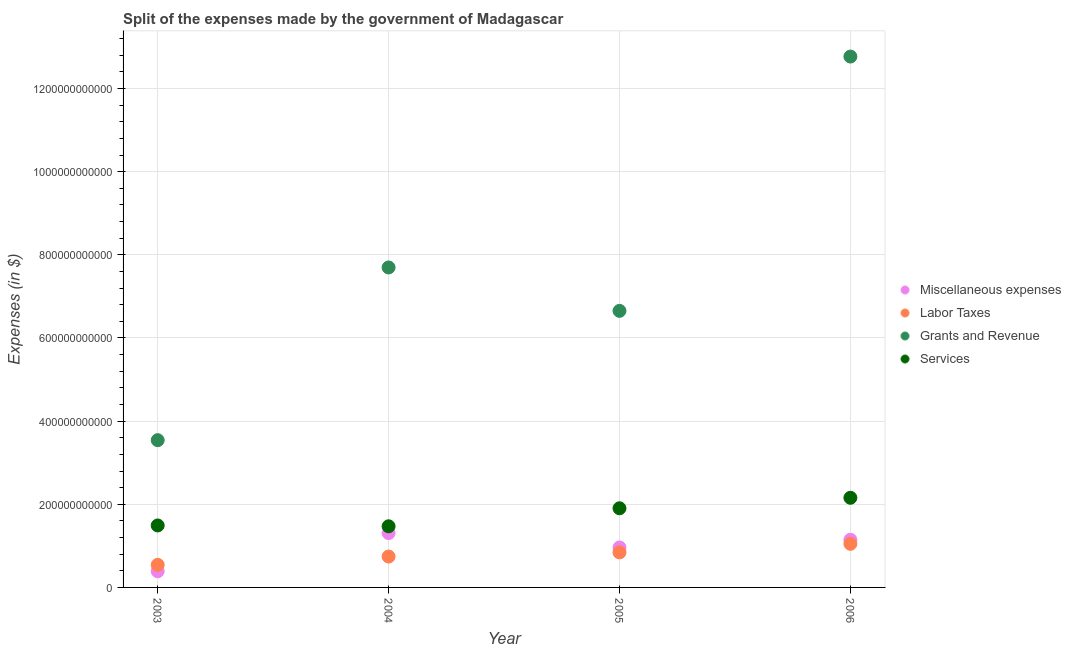How many different coloured dotlines are there?
Your answer should be compact. 4. Is the number of dotlines equal to the number of legend labels?
Keep it short and to the point. Yes. What is the amount spent on labor taxes in 2003?
Provide a succinct answer. 5.43e+1. Across all years, what is the maximum amount spent on labor taxes?
Provide a short and direct response. 1.05e+11. Across all years, what is the minimum amount spent on labor taxes?
Your response must be concise. 5.43e+1. In which year was the amount spent on services minimum?
Offer a very short reply. 2004. What is the total amount spent on miscellaneous expenses in the graph?
Ensure brevity in your answer.  3.80e+11. What is the difference between the amount spent on miscellaneous expenses in 2003 and that in 2005?
Give a very brief answer. -5.72e+1. What is the difference between the amount spent on miscellaneous expenses in 2003 and the amount spent on services in 2006?
Your answer should be compact. -1.77e+11. What is the average amount spent on labor taxes per year?
Offer a very short reply. 7.94e+1. In the year 2006, what is the difference between the amount spent on labor taxes and amount spent on services?
Ensure brevity in your answer.  -1.11e+11. In how many years, is the amount spent on services greater than 120000000000 $?
Make the answer very short. 4. What is the ratio of the amount spent on grants and revenue in 2005 to that in 2006?
Your response must be concise. 0.52. Is the amount spent on services in 2003 less than that in 2005?
Keep it short and to the point. Yes. Is the difference between the amount spent on grants and revenue in 2003 and 2006 greater than the difference between the amount spent on labor taxes in 2003 and 2006?
Your response must be concise. No. What is the difference between the highest and the second highest amount spent on services?
Ensure brevity in your answer.  2.52e+1. What is the difference between the highest and the lowest amount spent on services?
Offer a terse response. 6.86e+1. Does the amount spent on services monotonically increase over the years?
Ensure brevity in your answer.  No. Is the amount spent on miscellaneous expenses strictly greater than the amount spent on labor taxes over the years?
Make the answer very short. No. What is the difference between two consecutive major ticks on the Y-axis?
Your response must be concise. 2.00e+11. Does the graph contain grids?
Your response must be concise. Yes. Where does the legend appear in the graph?
Your answer should be very brief. Center right. How are the legend labels stacked?
Keep it short and to the point. Vertical. What is the title of the graph?
Offer a terse response. Split of the expenses made by the government of Madagascar. What is the label or title of the Y-axis?
Keep it short and to the point. Expenses (in $). What is the Expenses (in $) in Miscellaneous expenses in 2003?
Your answer should be compact. 3.89e+1. What is the Expenses (in $) in Labor Taxes in 2003?
Provide a short and direct response. 5.43e+1. What is the Expenses (in $) of Grants and Revenue in 2003?
Give a very brief answer. 3.54e+11. What is the Expenses (in $) in Services in 2003?
Ensure brevity in your answer.  1.49e+11. What is the Expenses (in $) of Miscellaneous expenses in 2004?
Your answer should be very brief. 1.31e+11. What is the Expenses (in $) in Labor Taxes in 2004?
Make the answer very short. 7.43e+1. What is the Expenses (in $) in Grants and Revenue in 2004?
Provide a short and direct response. 7.70e+11. What is the Expenses (in $) of Services in 2004?
Ensure brevity in your answer.  1.47e+11. What is the Expenses (in $) of Miscellaneous expenses in 2005?
Your answer should be compact. 9.61e+1. What is the Expenses (in $) in Labor Taxes in 2005?
Provide a short and direct response. 8.43e+1. What is the Expenses (in $) in Grants and Revenue in 2005?
Offer a very short reply. 6.65e+11. What is the Expenses (in $) in Services in 2005?
Offer a very short reply. 1.90e+11. What is the Expenses (in $) in Miscellaneous expenses in 2006?
Keep it short and to the point. 1.15e+11. What is the Expenses (in $) of Labor Taxes in 2006?
Offer a very short reply. 1.05e+11. What is the Expenses (in $) of Grants and Revenue in 2006?
Provide a short and direct response. 1.28e+12. What is the Expenses (in $) of Services in 2006?
Your answer should be compact. 2.16e+11. Across all years, what is the maximum Expenses (in $) of Miscellaneous expenses?
Offer a very short reply. 1.31e+11. Across all years, what is the maximum Expenses (in $) in Labor Taxes?
Your response must be concise. 1.05e+11. Across all years, what is the maximum Expenses (in $) in Grants and Revenue?
Offer a very short reply. 1.28e+12. Across all years, what is the maximum Expenses (in $) of Services?
Your answer should be compact. 2.16e+11. Across all years, what is the minimum Expenses (in $) of Miscellaneous expenses?
Offer a very short reply. 3.89e+1. Across all years, what is the minimum Expenses (in $) in Labor Taxes?
Your answer should be very brief. 5.43e+1. Across all years, what is the minimum Expenses (in $) in Grants and Revenue?
Offer a very short reply. 3.54e+11. Across all years, what is the minimum Expenses (in $) of Services?
Make the answer very short. 1.47e+11. What is the total Expenses (in $) of Miscellaneous expenses in the graph?
Make the answer very short. 3.80e+11. What is the total Expenses (in $) in Labor Taxes in the graph?
Provide a short and direct response. 3.18e+11. What is the total Expenses (in $) in Grants and Revenue in the graph?
Provide a succinct answer. 3.07e+12. What is the total Expenses (in $) in Services in the graph?
Offer a very short reply. 7.02e+11. What is the difference between the Expenses (in $) in Miscellaneous expenses in 2003 and that in 2004?
Offer a terse response. -9.17e+1. What is the difference between the Expenses (in $) in Labor Taxes in 2003 and that in 2004?
Give a very brief answer. -1.99e+1. What is the difference between the Expenses (in $) in Grants and Revenue in 2003 and that in 2004?
Keep it short and to the point. -4.15e+11. What is the difference between the Expenses (in $) in Services in 2003 and that in 2004?
Offer a terse response. 1.99e+09. What is the difference between the Expenses (in $) in Miscellaneous expenses in 2003 and that in 2005?
Ensure brevity in your answer.  -5.72e+1. What is the difference between the Expenses (in $) of Labor Taxes in 2003 and that in 2005?
Give a very brief answer. -3.00e+1. What is the difference between the Expenses (in $) in Grants and Revenue in 2003 and that in 2005?
Your answer should be compact. -3.11e+11. What is the difference between the Expenses (in $) in Services in 2003 and that in 2005?
Keep it short and to the point. -4.14e+1. What is the difference between the Expenses (in $) of Miscellaneous expenses in 2003 and that in 2006?
Your response must be concise. -7.57e+1. What is the difference between the Expenses (in $) of Labor Taxes in 2003 and that in 2006?
Make the answer very short. -5.06e+1. What is the difference between the Expenses (in $) of Grants and Revenue in 2003 and that in 2006?
Give a very brief answer. -9.23e+11. What is the difference between the Expenses (in $) of Services in 2003 and that in 2006?
Your response must be concise. -6.66e+1. What is the difference between the Expenses (in $) in Miscellaneous expenses in 2004 and that in 2005?
Ensure brevity in your answer.  3.46e+1. What is the difference between the Expenses (in $) of Labor Taxes in 2004 and that in 2005?
Give a very brief answer. -1.00e+1. What is the difference between the Expenses (in $) of Grants and Revenue in 2004 and that in 2005?
Your response must be concise. 1.04e+11. What is the difference between the Expenses (in $) of Services in 2004 and that in 2005?
Give a very brief answer. -4.33e+1. What is the difference between the Expenses (in $) in Miscellaneous expenses in 2004 and that in 2006?
Give a very brief answer. 1.61e+1. What is the difference between the Expenses (in $) of Labor Taxes in 2004 and that in 2006?
Provide a succinct answer. -3.06e+1. What is the difference between the Expenses (in $) of Grants and Revenue in 2004 and that in 2006?
Your answer should be very brief. -5.07e+11. What is the difference between the Expenses (in $) of Services in 2004 and that in 2006?
Offer a very short reply. -6.86e+1. What is the difference between the Expenses (in $) in Miscellaneous expenses in 2005 and that in 2006?
Your answer should be compact. -1.85e+1. What is the difference between the Expenses (in $) in Labor Taxes in 2005 and that in 2006?
Offer a terse response. -2.06e+1. What is the difference between the Expenses (in $) of Grants and Revenue in 2005 and that in 2006?
Your answer should be very brief. -6.12e+11. What is the difference between the Expenses (in $) of Services in 2005 and that in 2006?
Keep it short and to the point. -2.52e+1. What is the difference between the Expenses (in $) in Miscellaneous expenses in 2003 and the Expenses (in $) in Labor Taxes in 2004?
Give a very brief answer. -3.53e+1. What is the difference between the Expenses (in $) in Miscellaneous expenses in 2003 and the Expenses (in $) in Grants and Revenue in 2004?
Give a very brief answer. -7.31e+11. What is the difference between the Expenses (in $) of Miscellaneous expenses in 2003 and the Expenses (in $) of Services in 2004?
Make the answer very short. -1.08e+11. What is the difference between the Expenses (in $) of Labor Taxes in 2003 and the Expenses (in $) of Grants and Revenue in 2004?
Your answer should be compact. -7.15e+11. What is the difference between the Expenses (in $) in Labor Taxes in 2003 and the Expenses (in $) in Services in 2004?
Your answer should be compact. -9.27e+1. What is the difference between the Expenses (in $) in Grants and Revenue in 2003 and the Expenses (in $) in Services in 2004?
Provide a short and direct response. 2.07e+11. What is the difference between the Expenses (in $) of Miscellaneous expenses in 2003 and the Expenses (in $) of Labor Taxes in 2005?
Give a very brief answer. -4.54e+1. What is the difference between the Expenses (in $) in Miscellaneous expenses in 2003 and the Expenses (in $) in Grants and Revenue in 2005?
Keep it short and to the point. -6.26e+11. What is the difference between the Expenses (in $) in Miscellaneous expenses in 2003 and the Expenses (in $) in Services in 2005?
Provide a succinct answer. -1.51e+11. What is the difference between the Expenses (in $) of Labor Taxes in 2003 and the Expenses (in $) of Grants and Revenue in 2005?
Make the answer very short. -6.11e+11. What is the difference between the Expenses (in $) in Labor Taxes in 2003 and the Expenses (in $) in Services in 2005?
Offer a very short reply. -1.36e+11. What is the difference between the Expenses (in $) of Grants and Revenue in 2003 and the Expenses (in $) of Services in 2005?
Make the answer very short. 1.64e+11. What is the difference between the Expenses (in $) of Miscellaneous expenses in 2003 and the Expenses (in $) of Labor Taxes in 2006?
Make the answer very short. -6.60e+1. What is the difference between the Expenses (in $) in Miscellaneous expenses in 2003 and the Expenses (in $) in Grants and Revenue in 2006?
Your answer should be very brief. -1.24e+12. What is the difference between the Expenses (in $) of Miscellaneous expenses in 2003 and the Expenses (in $) of Services in 2006?
Your answer should be very brief. -1.77e+11. What is the difference between the Expenses (in $) in Labor Taxes in 2003 and the Expenses (in $) in Grants and Revenue in 2006?
Provide a short and direct response. -1.22e+12. What is the difference between the Expenses (in $) in Labor Taxes in 2003 and the Expenses (in $) in Services in 2006?
Your answer should be compact. -1.61e+11. What is the difference between the Expenses (in $) of Grants and Revenue in 2003 and the Expenses (in $) of Services in 2006?
Ensure brevity in your answer.  1.39e+11. What is the difference between the Expenses (in $) in Miscellaneous expenses in 2004 and the Expenses (in $) in Labor Taxes in 2005?
Provide a short and direct response. 4.64e+1. What is the difference between the Expenses (in $) of Miscellaneous expenses in 2004 and the Expenses (in $) of Grants and Revenue in 2005?
Keep it short and to the point. -5.35e+11. What is the difference between the Expenses (in $) of Miscellaneous expenses in 2004 and the Expenses (in $) of Services in 2005?
Provide a succinct answer. -5.97e+1. What is the difference between the Expenses (in $) of Labor Taxes in 2004 and the Expenses (in $) of Grants and Revenue in 2005?
Provide a succinct answer. -5.91e+11. What is the difference between the Expenses (in $) in Labor Taxes in 2004 and the Expenses (in $) in Services in 2005?
Provide a succinct answer. -1.16e+11. What is the difference between the Expenses (in $) in Grants and Revenue in 2004 and the Expenses (in $) in Services in 2005?
Keep it short and to the point. 5.79e+11. What is the difference between the Expenses (in $) of Miscellaneous expenses in 2004 and the Expenses (in $) of Labor Taxes in 2006?
Your answer should be very brief. 2.58e+1. What is the difference between the Expenses (in $) in Miscellaneous expenses in 2004 and the Expenses (in $) in Grants and Revenue in 2006?
Your answer should be very brief. -1.15e+12. What is the difference between the Expenses (in $) of Miscellaneous expenses in 2004 and the Expenses (in $) of Services in 2006?
Provide a short and direct response. -8.50e+1. What is the difference between the Expenses (in $) of Labor Taxes in 2004 and the Expenses (in $) of Grants and Revenue in 2006?
Ensure brevity in your answer.  -1.20e+12. What is the difference between the Expenses (in $) in Labor Taxes in 2004 and the Expenses (in $) in Services in 2006?
Offer a very short reply. -1.41e+11. What is the difference between the Expenses (in $) of Grants and Revenue in 2004 and the Expenses (in $) of Services in 2006?
Offer a terse response. 5.54e+11. What is the difference between the Expenses (in $) in Miscellaneous expenses in 2005 and the Expenses (in $) in Labor Taxes in 2006?
Your answer should be compact. -8.80e+09. What is the difference between the Expenses (in $) in Miscellaneous expenses in 2005 and the Expenses (in $) in Grants and Revenue in 2006?
Offer a very short reply. -1.18e+12. What is the difference between the Expenses (in $) of Miscellaneous expenses in 2005 and the Expenses (in $) of Services in 2006?
Make the answer very short. -1.20e+11. What is the difference between the Expenses (in $) in Labor Taxes in 2005 and the Expenses (in $) in Grants and Revenue in 2006?
Your answer should be very brief. -1.19e+12. What is the difference between the Expenses (in $) in Labor Taxes in 2005 and the Expenses (in $) in Services in 2006?
Your answer should be compact. -1.31e+11. What is the difference between the Expenses (in $) of Grants and Revenue in 2005 and the Expenses (in $) of Services in 2006?
Your answer should be compact. 4.50e+11. What is the average Expenses (in $) of Miscellaneous expenses per year?
Offer a terse response. 9.51e+1. What is the average Expenses (in $) of Labor Taxes per year?
Keep it short and to the point. 7.94e+1. What is the average Expenses (in $) in Grants and Revenue per year?
Ensure brevity in your answer.  7.66e+11. What is the average Expenses (in $) of Services per year?
Make the answer very short. 1.76e+11. In the year 2003, what is the difference between the Expenses (in $) in Miscellaneous expenses and Expenses (in $) in Labor Taxes?
Make the answer very short. -1.54e+1. In the year 2003, what is the difference between the Expenses (in $) of Miscellaneous expenses and Expenses (in $) of Grants and Revenue?
Keep it short and to the point. -3.15e+11. In the year 2003, what is the difference between the Expenses (in $) of Miscellaneous expenses and Expenses (in $) of Services?
Your answer should be very brief. -1.10e+11. In the year 2003, what is the difference between the Expenses (in $) of Labor Taxes and Expenses (in $) of Grants and Revenue?
Keep it short and to the point. -3.00e+11. In the year 2003, what is the difference between the Expenses (in $) in Labor Taxes and Expenses (in $) in Services?
Keep it short and to the point. -9.47e+1. In the year 2003, what is the difference between the Expenses (in $) in Grants and Revenue and Expenses (in $) in Services?
Offer a terse response. 2.05e+11. In the year 2004, what is the difference between the Expenses (in $) of Miscellaneous expenses and Expenses (in $) of Labor Taxes?
Your response must be concise. 5.64e+1. In the year 2004, what is the difference between the Expenses (in $) of Miscellaneous expenses and Expenses (in $) of Grants and Revenue?
Offer a terse response. -6.39e+11. In the year 2004, what is the difference between the Expenses (in $) of Miscellaneous expenses and Expenses (in $) of Services?
Make the answer very short. -1.64e+1. In the year 2004, what is the difference between the Expenses (in $) of Labor Taxes and Expenses (in $) of Grants and Revenue?
Offer a very short reply. -6.95e+11. In the year 2004, what is the difference between the Expenses (in $) of Labor Taxes and Expenses (in $) of Services?
Your answer should be very brief. -7.28e+1. In the year 2004, what is the difference between the Expenses (in $) of Grants and Revenue and Expenses (in $) of Services?
Offer a very short reply. 6.23e+11. In the year 2005, what is the difference between the Expenses (in $) in Miscellaneous expenses and Expenses (in $) in Labor Taxes?
Give a very brief answer. 1.18e+1. In the year 2005, what is the difference between the Expenses (in $) in Miscellaneous expenses and Expenses (in $) in Grants and Revenue?
Your response must be concise. -5.69e+11. In the year 2005, what is the difference between the Expenses (in $) in Miscellaneous expenses and Expenses (in $) in Services?
Keep it short and to the point. -9.43e+1. In the year 2005, what is the difference between the Expenses (in $) of Labor Taxes and Expenses (in $) of Grants and Revenue?
Your answer should be compact. -5.81e+11. In the year 2005, what is the difference between the Expenses (in $) of Labor Taxes and Expenses (in $) of Services?
Your answer should be very brief. -1.06e+11. In the year 2005, what is the difference between the Expenses (in $) in Grants and Revenue and Expenses (in $) in Services?
Offer a very short reply. 4.75e+11. In the year 2006, what is the difference between the Expenses (in $) in Miscellaneous expenses and Expenses (in $) in Labor Taxes?
Make the answer very short. 9.70e+09. In the year 2006, what is the difference between the Expenses (in $) in Miscellaneous expenses and Expenses (in $) in Grants and Revenue?
Provide a short and direct response. -1.16e+12. In the year 2006, what is the difference between the Expenses (in $) in Miscellaneous expenses and Expenses (in $) in Services?
Make the answer very short. -1.01e+11. In the year 2006, what is the difference between the Expenses (in $) in Labor Taxes and Expenses (in $) in Grants and Revenue?
Provide a short and direct response. -1.17e+12. In the year 2006, what is the difference between the Expenses (in $) of Labor Taxes and Expenses (in $) of Services?
Your answer should be very brief. -1.11e+11. In the year 2006, what is the difference between the Expenses (in $) of Grants and Revenue and Expenses (in $) of Services?
Offer a terse response. 1.06e+12. What is the ratio of the Expenses (in $) of Miscellaneous expenses in 2003 to that in 2004?
Offer a terse response. 0.3. What is the ratio of the Expenses (in $) in Labor Taxes in 2003 to that in 2004?
Provide a short and direct response. 0.73. What is the ratio of the Expenses (in $) in Grants and Revenue in 2003 to that in 2004?
Make the answer very short. 0.46. What is the ratio of the Expenses (in $) of Services in 2003 to that in 2004?
Give a very brief answer. 1.01. What is the ratio of the Expenses (in $) in Miscellaneous expenses in 2003 to that in 2005?
Your answer should be compact. 0.41. What is the ratio of the Expenses (in $) in Labor Taxes in 2003 to that in 2005?
Provide a succinct answer. 0.64. What is the ratio of the Expenses (in $) in Grants and Revenue in 2003 to that in 2005?
Your answer should be compact. 0.53. What is the ratio of the Expenses (in $) in Services in 2003 to that in 2005?
Your response must be concise. 0.78. What is the ratio of the Expenses (in $) of Miscellaneous expenses in 2003 to that in 2006?
Make the answer very short. 0.34. What is the ratio of the Expenses (in $) of Labor Taxes in 2003 to that in 2006?
Your answer should be compact. 0.52. What is the ratio of the Expenses (in $) of Grants and Revenue in 2003 to that in 2006?
Your answer should be compact. 0.28. What is the ratio of the Expenses (in $) in Services in 2003 to that in 2006?
Ensure brevity in your answer.  0.69. What is the ratio of the Expenses (in $) in Miscellaneous expenses in 2004 to that in 2005?
Make the answer very short. 1.36. What is the ratio of the Expenses (in $) in Labor Taxes in 2004 to that in 2005?
Keep it short and to the point. 0.88. What is the ratio of the Expenses (in $) in Grants and Revenue in 2004 to that in 2005?
Keep it short and to the point. 1.16. What is the ratio of the Expenses (in $) in Services in 2004 to that in 2005?
Offer a very short reply. 0.77. What is the ratio of the Expenses (in $) in Miscellaneous expenses in 2004 to that in 2006?
Offer a terse response. 1.14. What is the ratio of the Expenses (in $) of Labor Taxes in 2004 to that in 2006?
Your response must be concise. 0.71. What is the ratio of the Expenses (in $) of Grants and Revenue in 2004 to that in 2006?
Your answer should be compact. 0.6. What is the ratio of the Expenses (in $) in Services in 2004 to that in 2006?
Ensure brevity in your answer.  0.68. What is the ratio of the Expenses (in $) of Miscellaneous expenses in 2005 to that in 2006?
Offer a very short reply. 0.84. What is the ratio of the Expenses (in $) in Labor Taxes in 2005 to that in 2006?
Make the answer very short. 0.8. What is the ratio of the Expenses (in $) in Grants and Revenue in 2005 to that in 2006?
Keep it short and to the point. 0.52. What is the ratio of the Expenses (in $) in Services in 2005 to that in 2006?
Ensure brevity in your answer.  0.88. What is the difference between the highest and the second highest Expenses (in $) in Miscellaneous expenses?
Your answer should be very brief. 1.61e+1. What is the difference between the highest and the second highest Expenses (in $) of Labor Taxes?
Provide a short and direct response. 2.06e+1. What is the difference between the highest and the second highest Expenses (in $) of Grants and Revenue?
Your response must be concise. 5.07e+11. What is the difference between the highest and the second highest Expenses (in $) of Services?
Offer a terse response. 2.52e+1. What is the difference between the highest and the lowest Expenses (in $) of Miscellaneous expenses?
Give a very brief answer. 9.17e+1. What is the difference between the highest and the lowest Expenses (in $) of Labor Taxes?
Give a very brief answer. 5.06e+1. What is the difference between the highest and the lowest Expenses (in $) of Grants and Revenue?
Offer a very short reply. 9.23e+11. What is the difference between the highest and the lowest Expenses (in $) in Services?
Offer a terse response. 6.86e+1. 